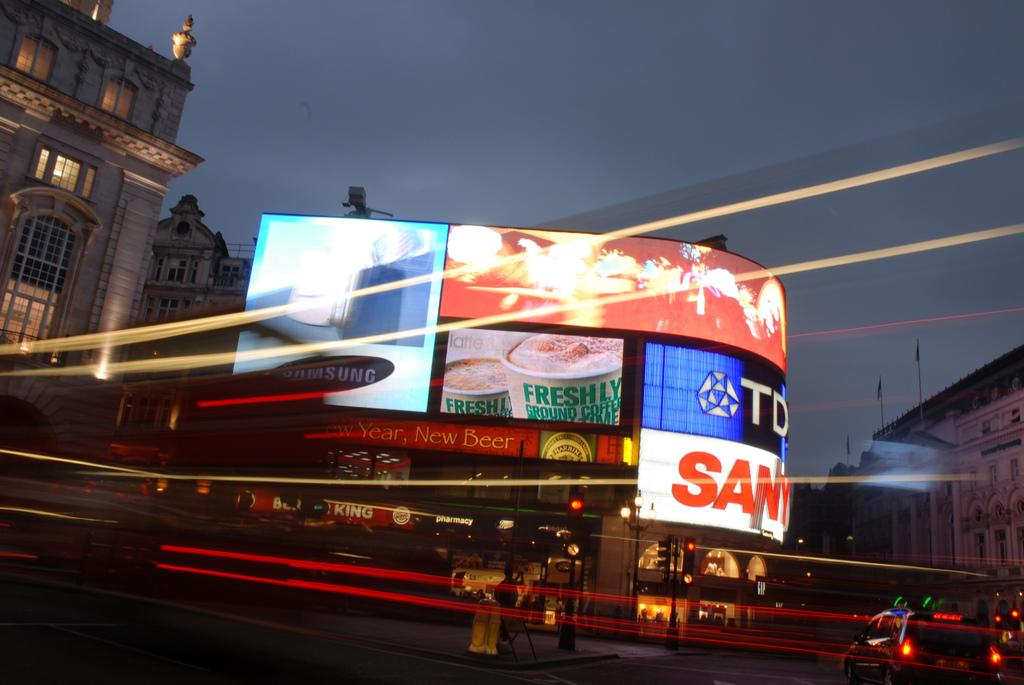<image>
Create a compact narrative representing the image presented. A busy street at night and a samsung ad high above the side streets. 